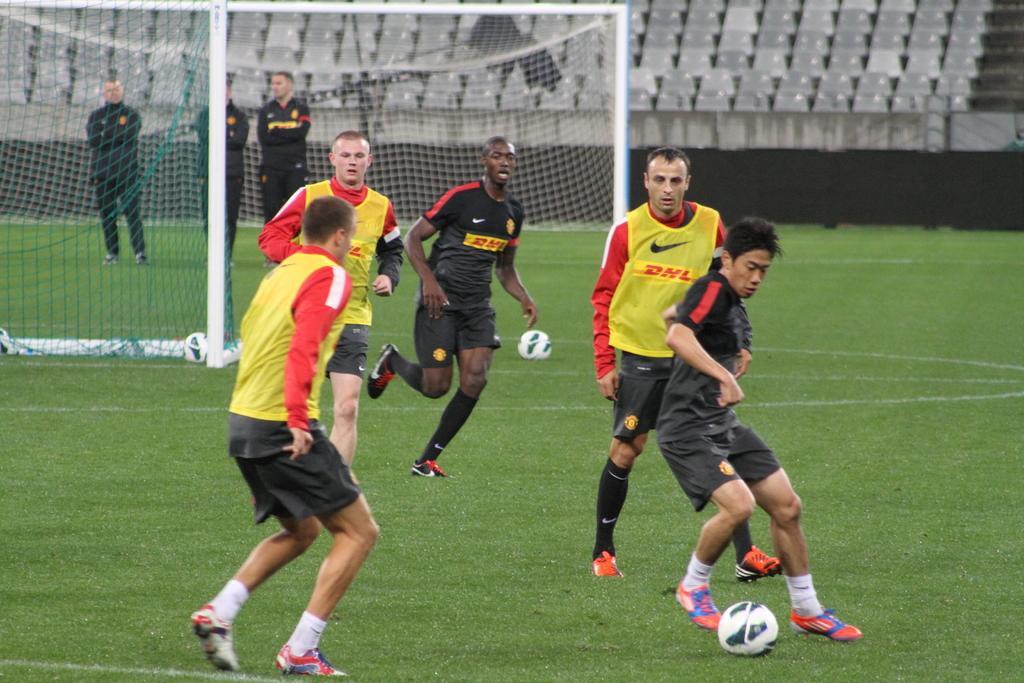Describe this image in one or two sentences. In this image I can see grass ground and on it I can see white lines, a goal post and few people are standing. I can also see a white color football and in the background I can see number of chairs. 